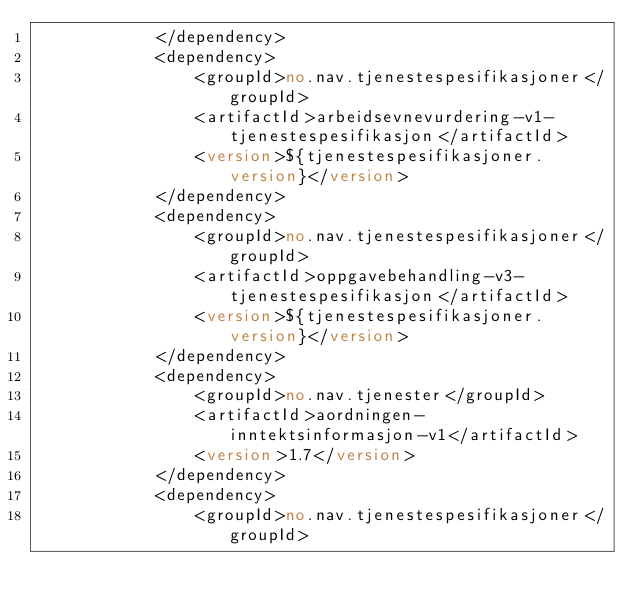<code> <loc_0><loc_0><loc_500><loc_500><_XML_>            </dependency>
            <dependency>
                <groupId>no.nav.tjenestespesifikasjoner</groupId>
                <artifactId>arbeidsevnevurdering-v1-tjenestespesifikasjon</artifactId>
                <version>${tjenestespesifikasjoner.version}</version>
            </dependency>
            <dependency>
                <groupId>no.nav.tjenestespesifikasjoner</groupId>
                <artifactId>oppgavebehandling-v3-tjenestespesifikasjon</artifactId>
                <version>${tjenestespesifikasjoner.version}</version>
            </dependency>
            <dependency>
                <groupId>no.nav.tjenester</groupId>
                <artifactId>aordningen-inntektsinformasjon-v1</artifactId>
                <version>1.7</version>
            </dependency>
            <dependency>
                <groupId>no.nav.tjenestespesifikasjoner</groupId></code> 